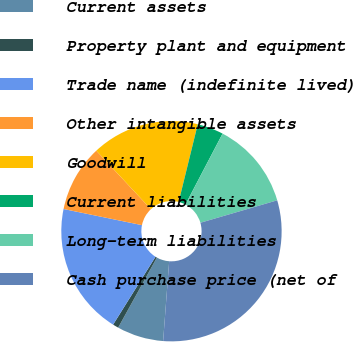Convert chart to OTSL. <chart><loc_0><loc_0><loc_500><loc_500><pie_chart><fcel>Current assets<fcel>Property plant and equipment<fcel>Trade name (indefinite lived)<fcel>Other intangible assets<fcel>Goodwill<fcel>Current liabilities<fcel>Long-term liabilities<fcel>Cash purchase price (net of<nl><fcel>6.83%<fcel>0.85%<fcel>19.34%<fcel>9.82%<fcel>15.79%<fcel>3.84%<fcel>12.8%<fcel>30.73%<nl></chart> 